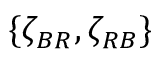Convert formula to latex. <formula><loc_0><loc_0><loc_500><loc_500>\{ \zeta _ { B R } , \zeta _ { R B } \}</formula> 